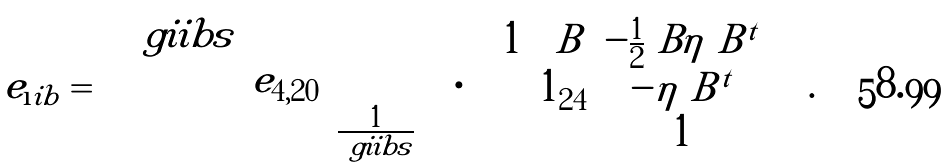<formula> <loc_0><loc_0><loc_500><loc_500>e _ { \i i b } = \begin{pmatrix} \ g i i b s & & \\ & e _ { 4 , 2 0 } & \\ & & \frac { 1 } { \ g i i b s } \end{pmatrix} \cdot \begin{pmatrix} 1 & \ B & - \frac { 1 } { 2 } \ B \eta \ B ^ { t } \\ & 1 _ { 2 4 } & - \eta \ B ^ { t } \\ & & 1 \end{pmatrix} \ .</formula> 